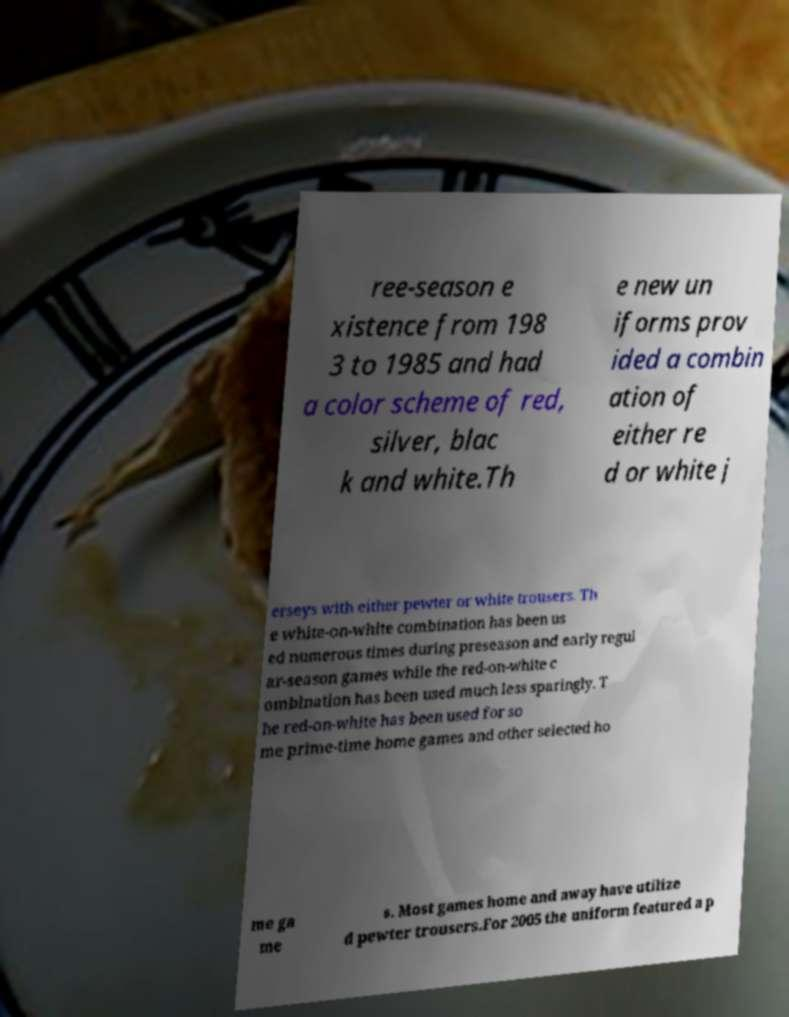Can you accurately transcribe the text from the provided image for me? ree-season e xistence from 198 3 to 1985 and had a color scheme of red, silver, blac k and white.Th e new un iforms prov ided a combin ation of either re d or white j erseys with either pewter or white trousers. Th e white-on-white combination has been us ed numerous times during preseason and early regul ar-season games while the red-on-white c ombination has been used much less sparingly. T he red-on-white has been used for so me prime-time home games and other selected ho me ga me s. Most games home and away have utilize d pewter trousers.For 2005 the uniform featured a p 